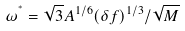<formula> <loc_0><loc_0><loc_500><loc_500>\omega ^ { ^ { * } } = { \sqrt { 3 } A ^ { 1 / 6 } ( \delta f ) ^ { 1 / 3 } / \sqrt { M } }</formula> 